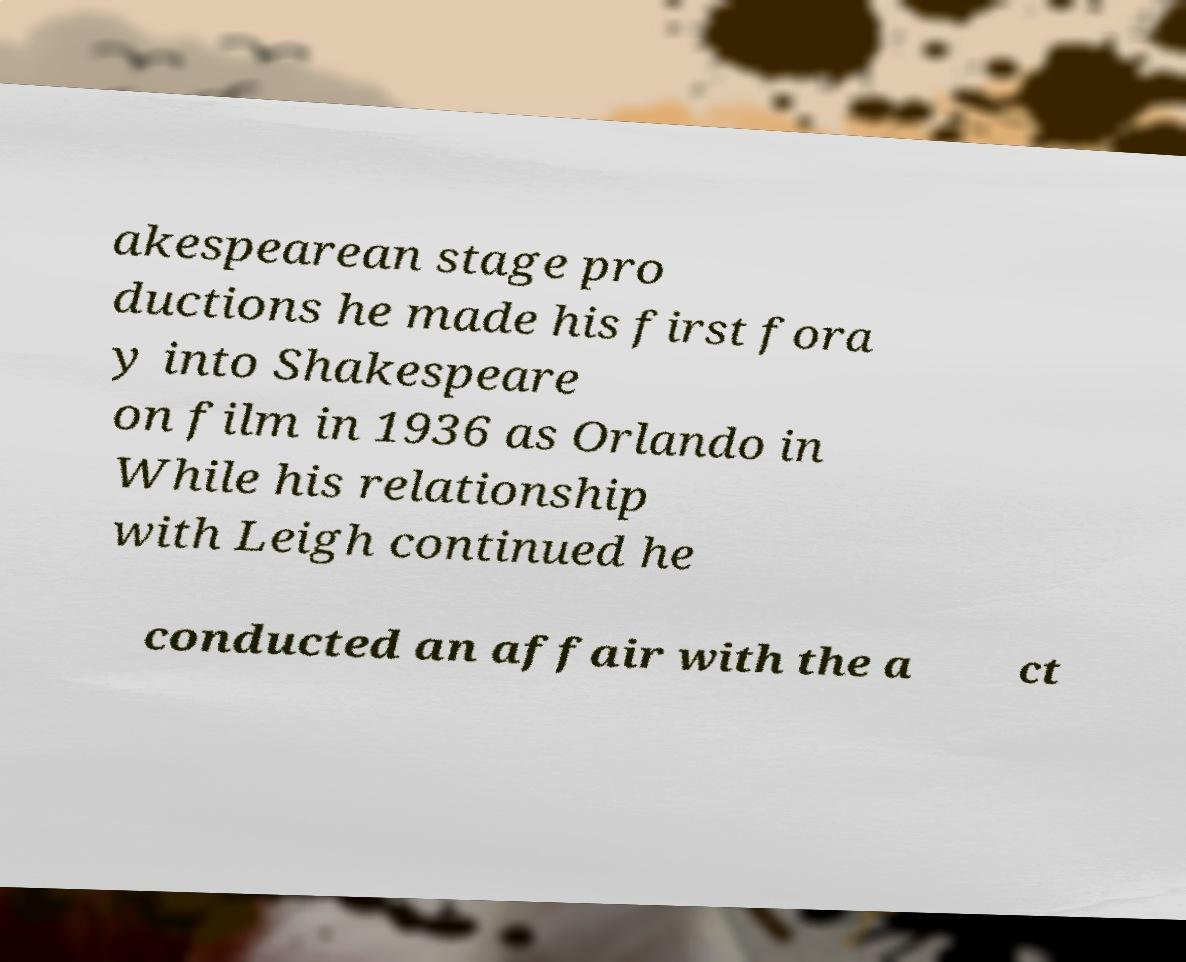Can you accurately transcribe the text from the provided image for me? akespearean stage pro ductions he made his first fora y into Shakespeare on film in 1936 as Orlando in While his relationship with Leigh continued he conducted an affair with the a ct 